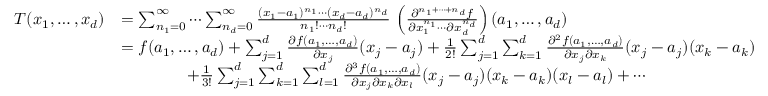<formula> <loc_0><loc_0><loc_500><loc_500>{ \begin{array} { r l } { T ( x _ { 1 } , \dots , x _ { d } ) } & { = \sum _ { n _ { 1 } = 0 } ^ { \infty } \cdots \sum _ { n _ { d } = 0 } ^ { \infty } { \frac { ( x _ { 1 } - a _ { 1 } ) ^ { n _ { 1 } } \cdots ( x _ { d } - a _ { d } ) ^ { n _ { d } } } { n _ { 1 } ! \cdots n _ { d } ! } } \, \left ( { \frac { \partial ^ { n _ { 1 } + \cdots + n _ { d } } f } { \partial x _ { 1 } ^ { n _ { 1 } } \cdots \partial x _ { d } ^ { n _ { d } } } } \right ) ( a _ { 1 } , \dots , a _ { d } ) } \\ & { = f ( a _ { 1 } , \dots , a _ { d } ) + \sum _ { j = 1 } ^ { d } { \frac { \partial f ( a _ { 1 } , \dots , a _ { d } ) } { \partial x _ { j } } } ( x _ { j } - a _ { j } ) + { \frac { 1 } { 2 ! } } \sum _ { j = 1 } ^ { d } \sum _ { k = 1 } ^ { d } { \frac { \partial ^ { 2 } f ( a _ { 1 } , \dots , a _ { d } ) } { \partial x _ { j } \partial x _ { k } } } ( x _ { j } - a _ { j } ) ( x _ { k } - a _ { k } ) } \\ & { \quad + { \frac { 1 } { 3 ! } } \sum _ { j = 1 } ^ { d } \sum _ { k = 1 } ^ { d } \sum _ { l = 1 } ^ { d } { \frac { \partial ^ { 3 } f ( a _ { 1 } , \dots , a _ { d } ) } { \partial x _ { j } \partial x _ { k } \partial x _ { l } } } ( x _ { j } - a _ { j } ) ( x _ { k } - a _ { k } ) ( x _ { l } - a _ { l } ) + \cdots } \end{array} }</formula> 